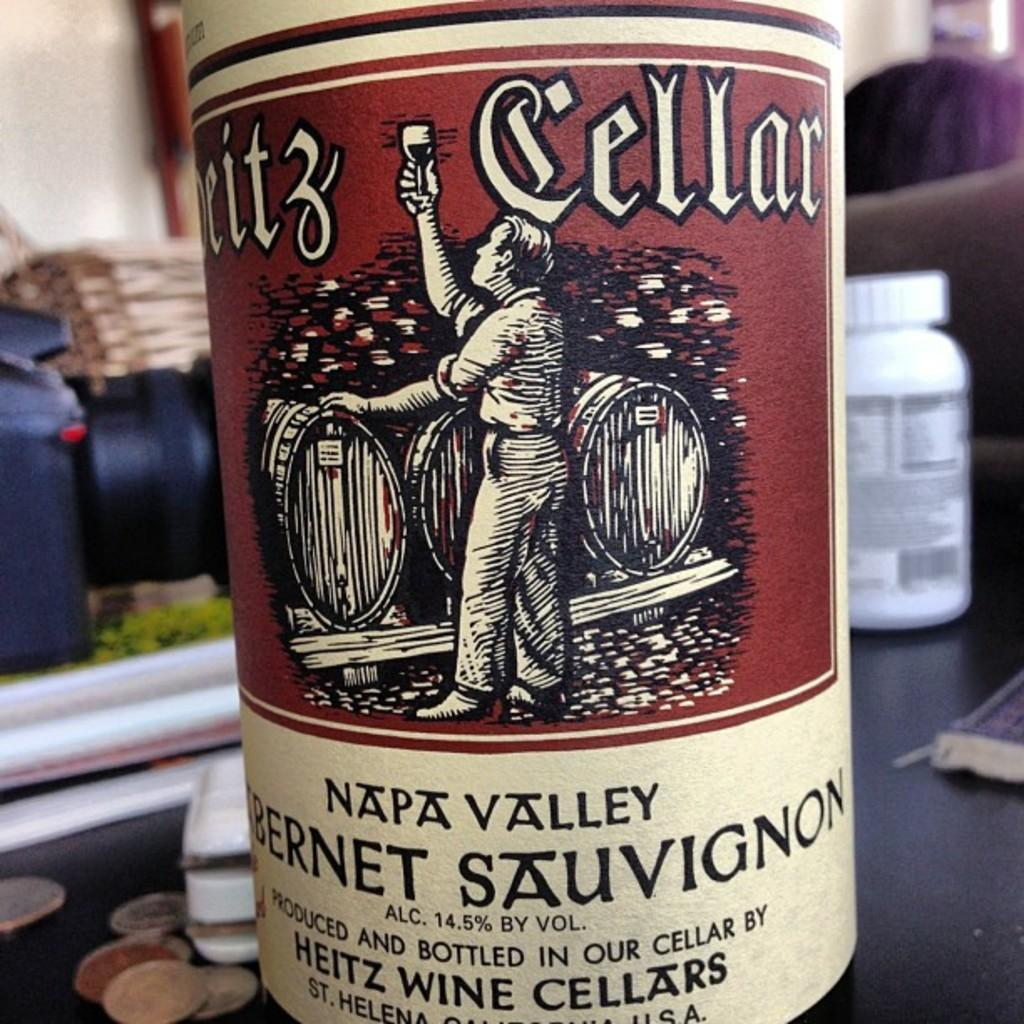What is the main object in the picture? There is a wine bottle in the picture. What is unique about the wine bottle? The wine bottle has a sticker on it. Can you describe the sticker on the wine bottle? The sticker is in maroon and cream color. Where is the wine bottle located in the image? The wine bottle is placed on a table. How would you describe the background of the image? The background of the image is blurred. What type of appliance can be seen in the image? There is no appliance present in the image; it features a wine bottle with a sticker on it. What division is responsible for the design of the sticker on the wine bottle? There is no information about the division responsible for the design of the sticker in the image. 